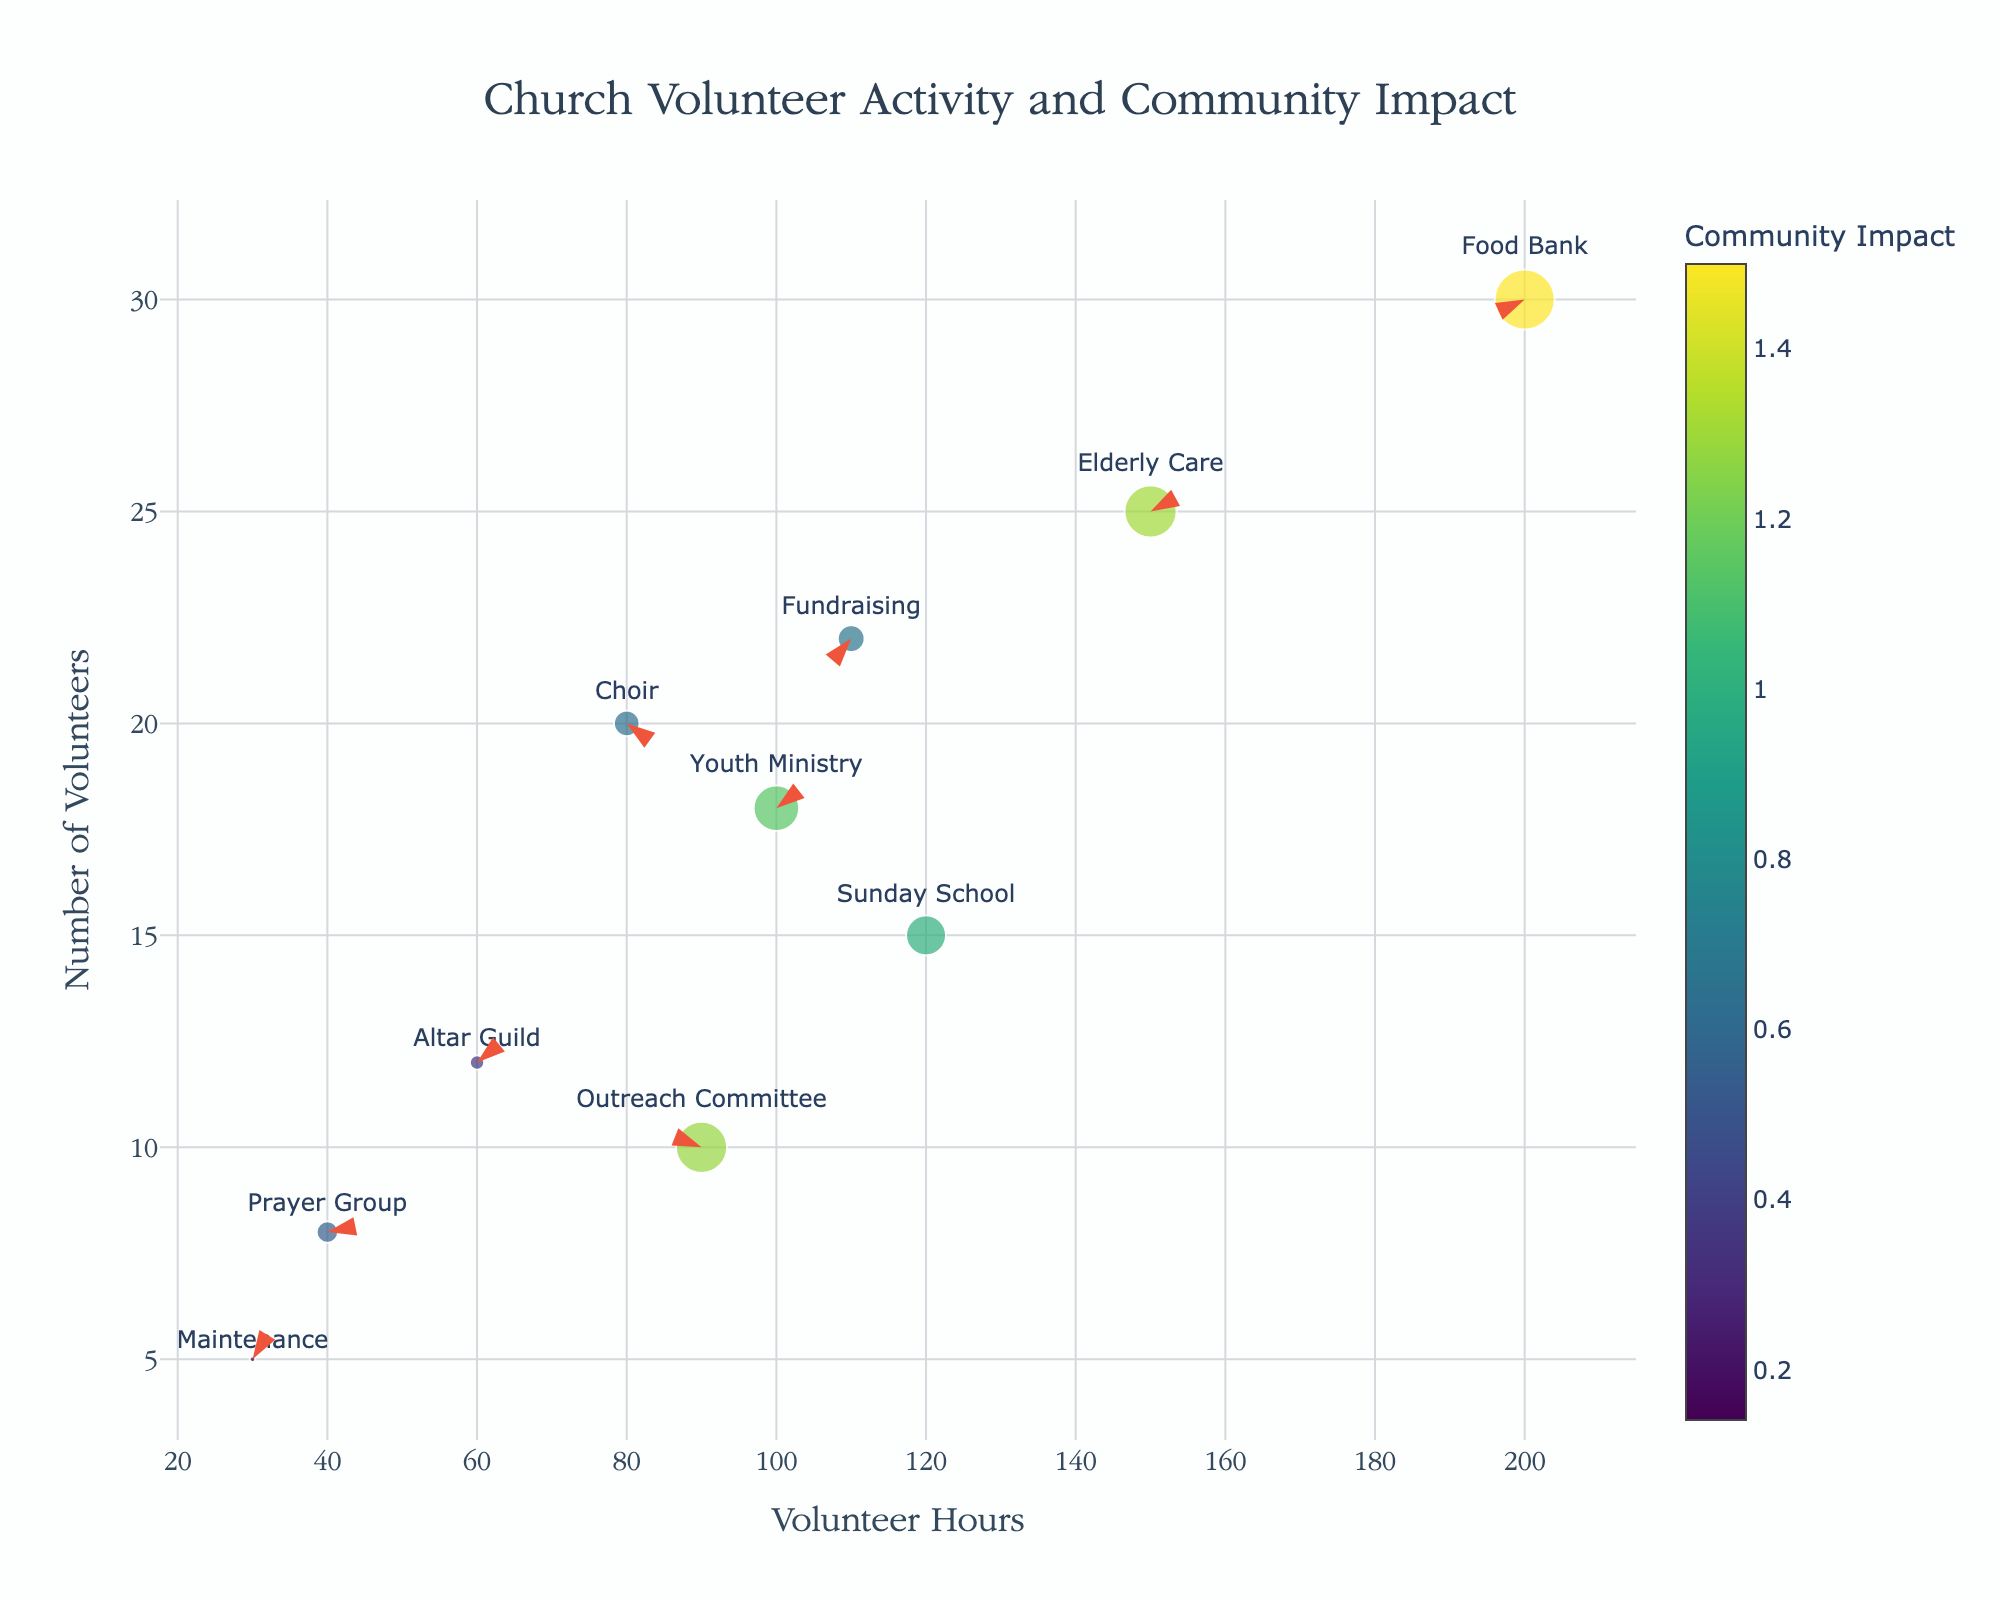What is the title of the figure? The title of the figure is clearly displayed at the top.
Answer: Church Volunteer Activity and Community Impact Which department has the highest community impact magnitude? The department with the highest community impact magnitude has the longest arrow length, indicated by large circles.
Answer: Food Bank How many departments are shown in the figure? The number of departments can be counted from the text labels next to the data points.
Answer: 10 Which department has the least number of volunteer hours? Look for the data point positioned furthest to the left on the x-axis (Volunteer Hours axis).
Answer: Maintenance How does the community impact compare between the Food Bank and Fundraising departments? The Food Bank has a significantly higher community impact magnitude compared to the Fundraising department, visible by the larger circle size and longer arrow pointing from their respective positions.
Answer: Food Bank has a higher impact than Fundraising What is the average number of volunteers across all the departments? Sum all the volunteer numbers for each department and divide by the total number of departments (10).
Answer: 16.5 Which department's arrow indicates the steepest angle with respect to the horizontal axis? The steepest angle can be identified by the arrow with the largest y-component of the community impact relative to its x-component.
Answer: Elderly Care How does the community impact of the Choir compare to the Sunday School? By comparing the arrow lengths and circle sizes of the respective departments, it is seen that the impact for the Choir is smaller than that for the Sunday School.
Answer: Choir has a smaller impact than Sunday School What is the community impact vector (magnitude and direction) for the Elderly Care department? The Elderly Care department's coordinates on the impact direction provide magnitude via arrow length and angle interpretation from the direction. Magnitude: sqrt(0.7^2 + 1.1^2) = 1.30 and angle atan(1.1/0.7).
Answer: Magnitude: 1.30, Angle: 57.53 degrees Between the Prayer Group and the Altar Guild, which has more volunteers and greater community impact? Compare the volunteers’ count (y-coordinate) and impact vector (circle size and length) for both groups.
Answer: Altar Guild has more volunteers and greater impact 